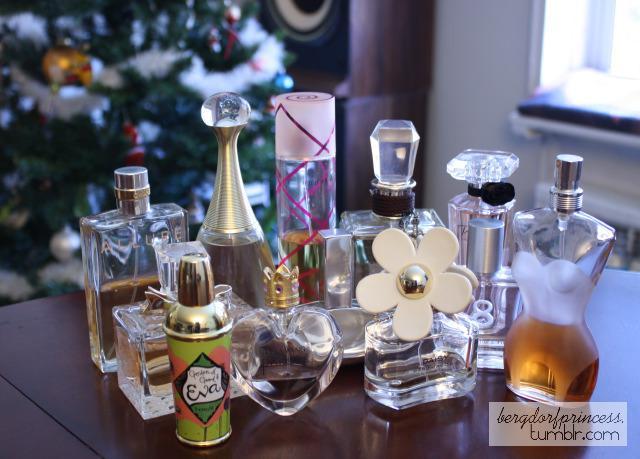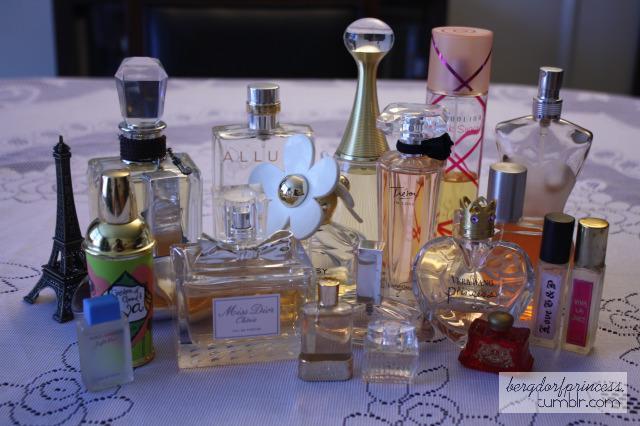The first image is the image on the left, the second image is the image on the right. Given the left and right images, does the statement "The left image shows a collection of fragrance bottles on a tray, and the leftmost bottle in the front row has a round black cap." hold true? Answer yes or no. No. 